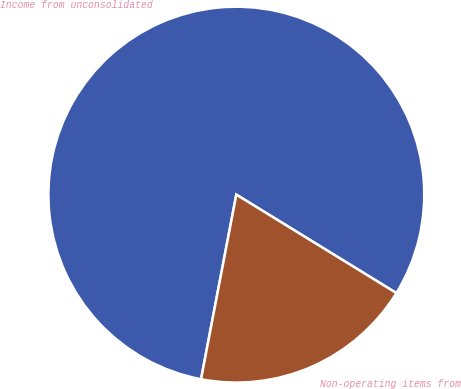Convert chart to OTSL. <chart><loc_0><loc_0><loc_500><loc_500><pie_chart><fcel>Income from unconsolidated<fcel>Non-operating items from<nl><fcel>80.77%<fcel>19.23%<nl></chart> 